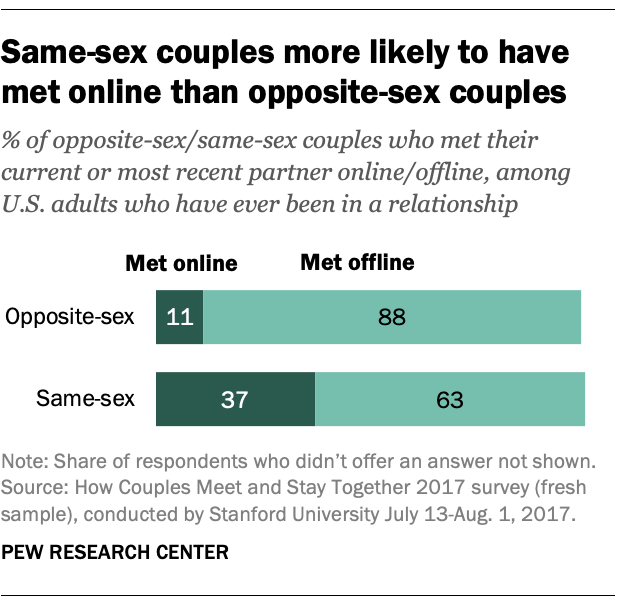Identify some key points in this picture. The average number of bars visited by people in the opposite-sex category is less than the average number of bars visited by people in the same-sex category, according to the data provided. Approximately 11% of those who met their opposite-sex partners online. 